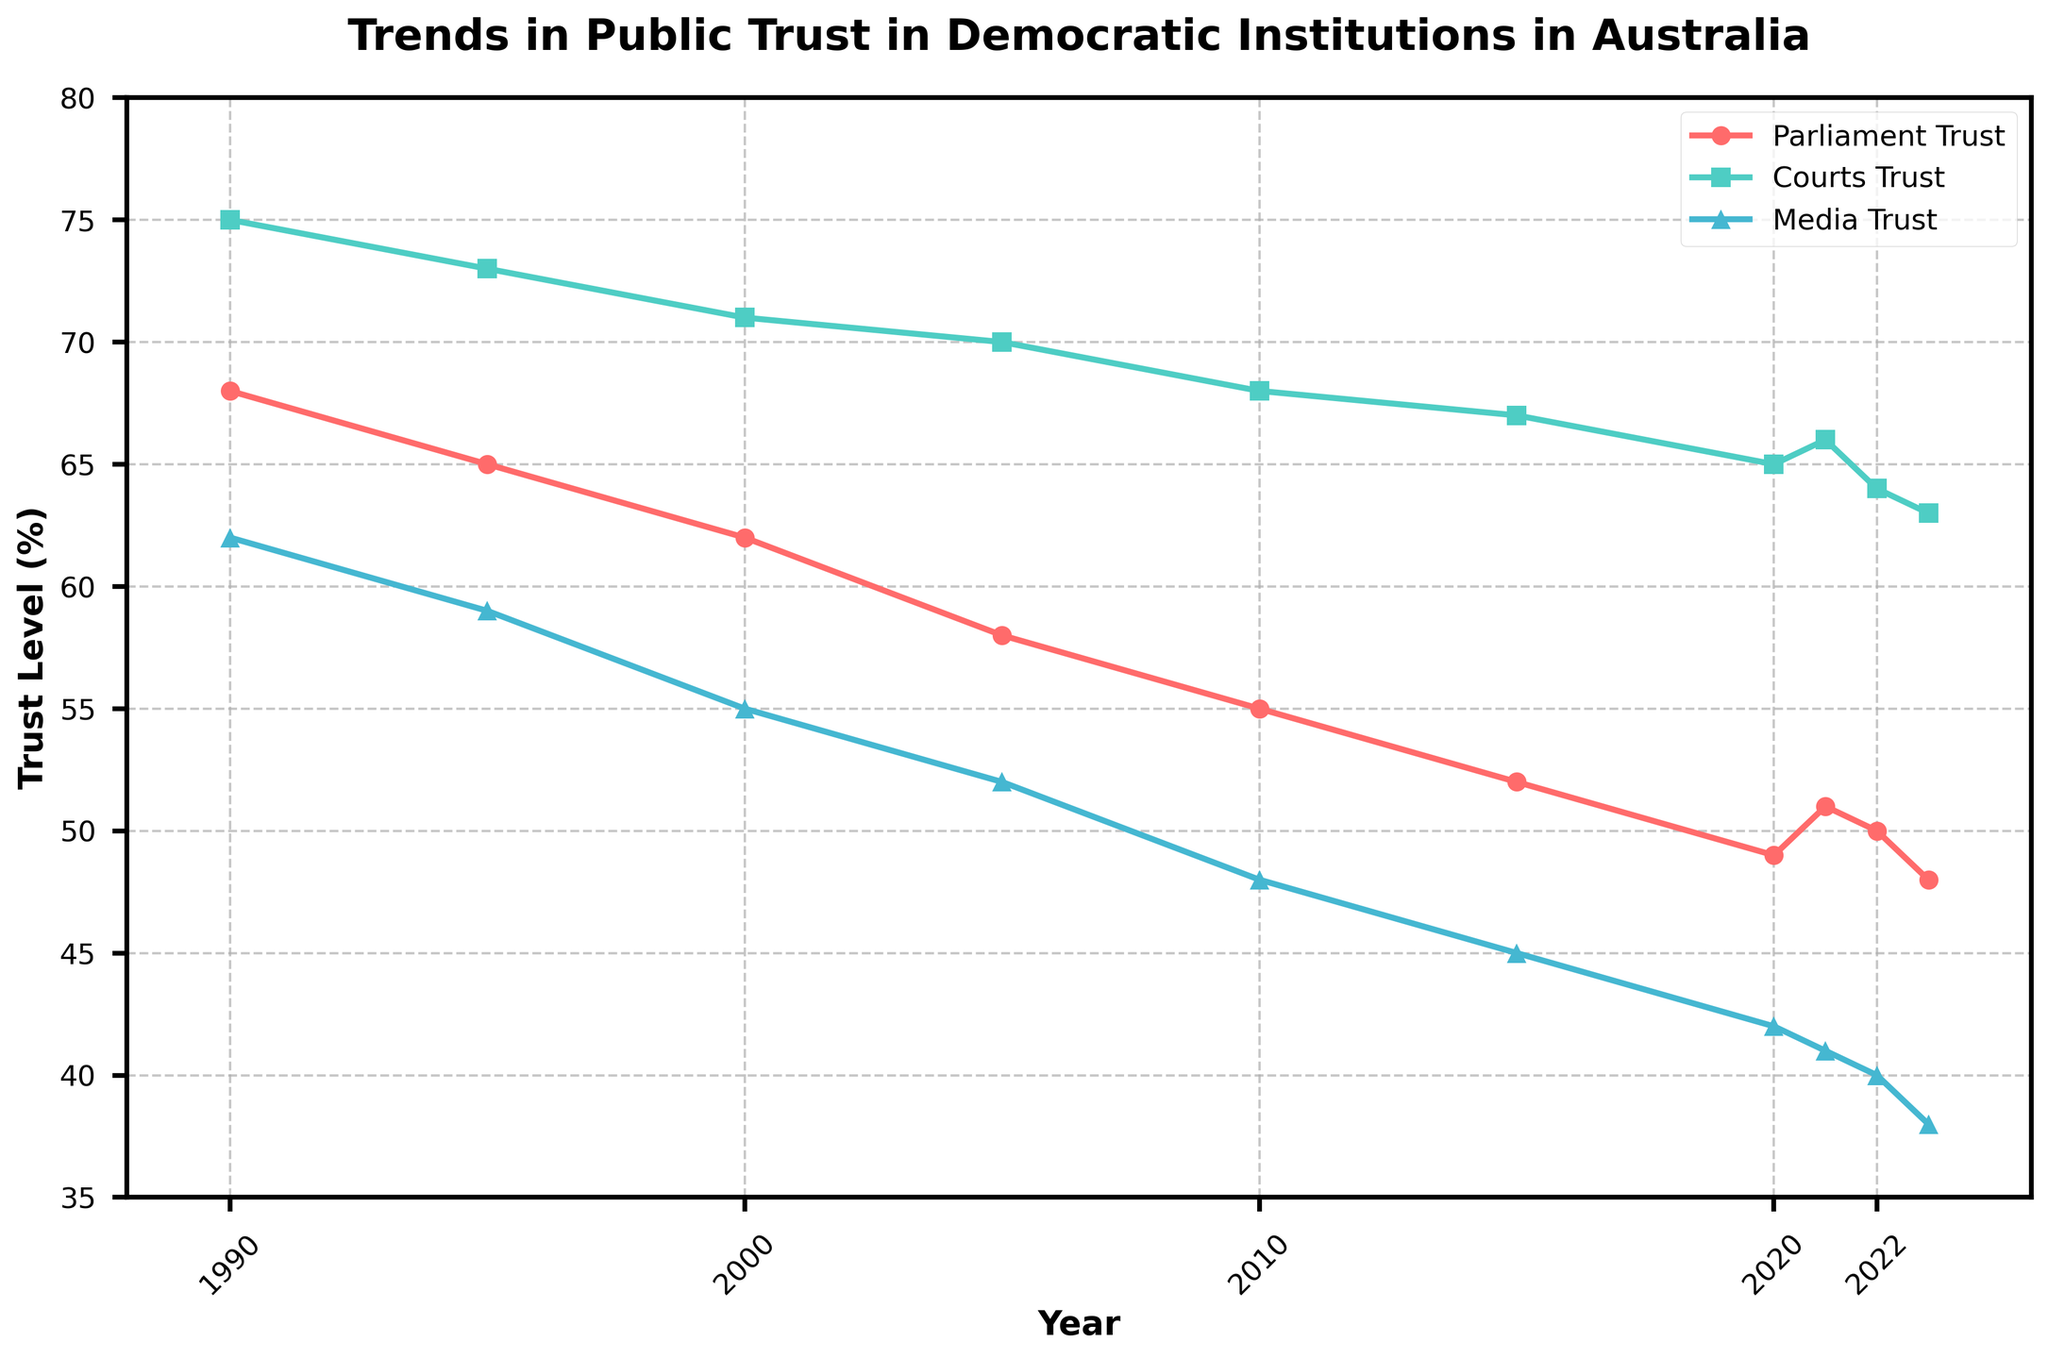What is the trend in public trust in parliament from 1990 to 2023? The trust in parliament steadily declines from 68% in 1990 to 48% in 2023. The observation shows a gradual decrease over the years.
Answer: Steadily declines Which institution had the highest level of trust in 2000? By examining the values for 2000, the Courts Trust is 71%, whereas the Parliament Trust is 62% and the Media Trust is 55%. Hence, the Courts Trust had the highest level of trust.
Answer: Courts Trust How did trust in media change from 2010 to 2023? Trust in media decreased consistently from 48% in 2010 to 38% in 2023, showing a downward trend.
Answer: Decreased Between 2015 and 2020, which institution experienced the greatest decrease in trust? The Parliament Trust decreased from 52% to 49% (a 3% drop), Courts Trust from 67% to 65% (a 2% drop), and Media Trust from 45% to 42% (a 3% drop). Therefore, both Parliament and Media Trust experienced the greatest decrease.
Answer: Parliament and Media Trust What was the difference in trust levels between the courts and parliament in 1990? In 1990, the Courts Trust was 75% while the Parliament Trust was 68%. The difference is 75% - 68% = 7%.
Answer: 7% Describe the pattern of trust in the courts from 2000 to 2023. The trust in the courts has a downward trend from 71% in 2000 to 63% in 2023. It experiences relatively smaller decreases compared to other institutions.
Answer: Downward trend In which year did the trust levels for media drop to below 50%? According to the data, the trust levels for media dropped below 50% in 2005, where it was recorded at 52% in 2005.
Answer: 2005 Which years show an increase in trust for at least one institution? Comparing year-to-year values, 2021 shows an increase from 2020 for Parliament (49% to 51%) and Courts (65% to 66%). No other years indicate an increase.
Answer: 2021 What is the average trust level for the courts from 1990 to 2023? Adding all the values for Courts Trust from 1990 to 2023 (75, 73, 71, 70, 68, 67, 65, 66, 64, 63) and dividing by the number of years, (75+73+71+70+68+67+65+66+64+63)/10 = 68.2%.
Answer: 68.2% How does the trend in public trust in democratic institutions in Australia reflect the general sentiment towards such institutions? Over the period from 1990 to 2023, there is a clear downward trend in trust in all the institutions, indicating a general decline in public confidence in democratic institutions in Australia.
Answer: General decline 